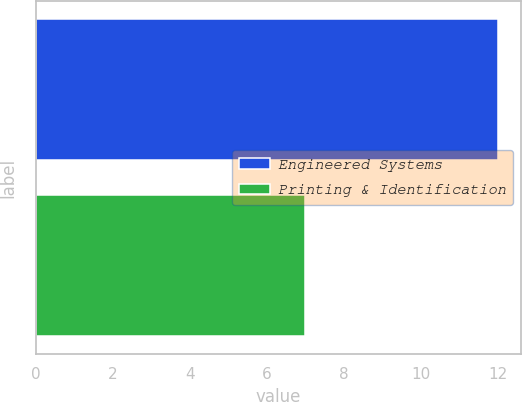Convert chart to OTSL. <chart><loc_0><loc_0><loc_500><loc_500><bar_chart><fcel>Engineered Systems<fcel>Printing & Identification<nl><fcel>12<fcel>7<nl></chart> 